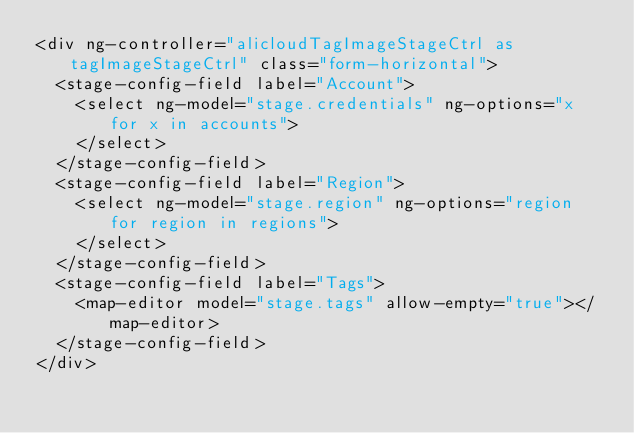<code> <loc_0><loc_0><loc_500><loc_500><_HTML_><div ng-controller="alicloudTagImageStageCtrl as tagImageStageCtrl" class="form-horizontal">
  <stage-config-field label="Account">
    <select ng-model="stage.credentials" ng-options="x for x in accounts">
    </select>
  </stage-config-field>
  <stage-config-field label="Region">
    <select ng-model="stage.region" ng-options="region for region in regions">
    </select>
  </stage-config-field>
  <stage-config-field label="Tags">
    <map-editor model="stage.tags" allow-empty="true"></map-editor>
  </stage-config-field>
</div>
</code> 